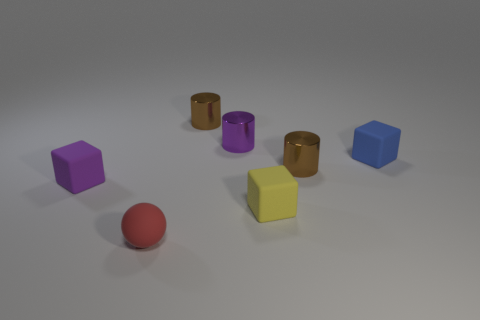Subtract all purple blocks. How many blocks are left? 2 Add 2 spheres. How many objects exist? 9 Subtract all yellow blocks. How many brown cylinders are left? 2 Subtract all yellow cylinders. Subtract all yellow balls. How many cylinders are left? 3 Subtract 0 blue cylinders. How many objects are left? 7 Subtract all cubes. How many objects are left? 4 Subtract all purple rubber objects. Subtract all small blue cubes. How many objects are left? 5 Add 6 blue blocks. How many blue blocks are left? 7 Add 5 blue blocks. How many blue blocks exist? 6 